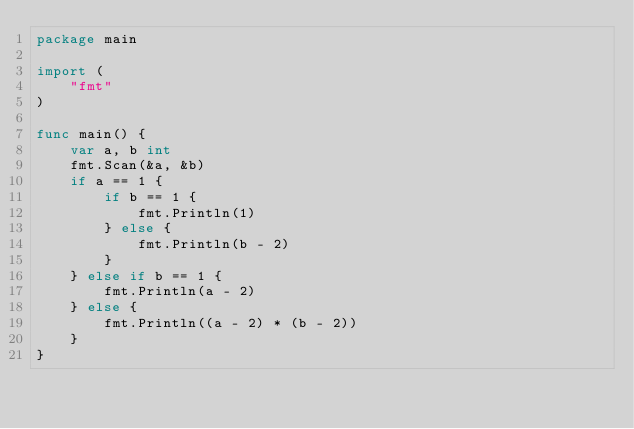Convert code to text. <code><loc_0><loc_0><loc_500><loc_500><_Go_>package main

import (
    "fmt"
)

func main() {
    var a, b int 
    fmt.Scan(&a, &b) 
    if a == 1 { 
        if b == 1 { 
            fmt.Println(1)
        } else {
            fmt.Println(b - 2)
        }   
    } else if b == 1 { 
        fmt.Println(a - 2)
    } else {
        fmt.Println((a - 2) * (b - 2)) 
    }   
}
</code> 